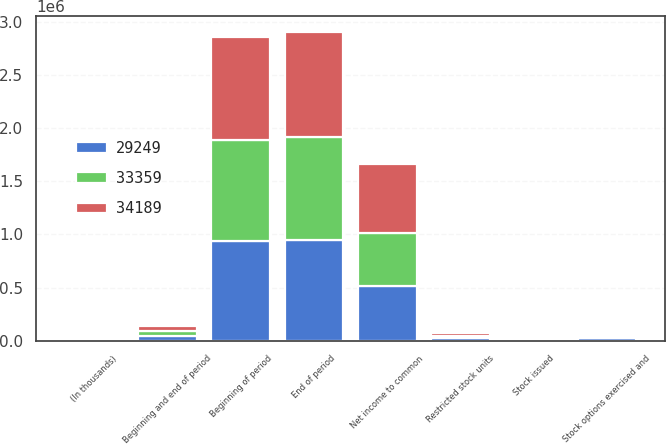Convert chart. <chart><loc_0><loc_0><loc_500><loc_500><stacked_bar_chart><ecel><fcel>(In thousands)<fcel>Beginning and end of period<fcel>Beginning of period<fcel>Stock options exercised and<fcel>Restricted stock units<fcel>Stock issued<fcel>End of period<fcel>Net income to common<nl><fcel>34189<fcel>2014<fcel>47024<fcel>967440<fcel>4485<fcel>27966<fcel>591<fcel>991512<fcel>648884<nl><fcel>33359<fcel>2013<fcel>47024<fcel>945166<fcel>1143<fcel>22881<fcel>536<fcel>967440<fcel>499925<nl><fcel>29249<fcel>2012<fcel>47024<fcel>941109<fcel>22125<fcel>25728<fcel>454<fcel>945166<fcel>510592<nl></chart> 